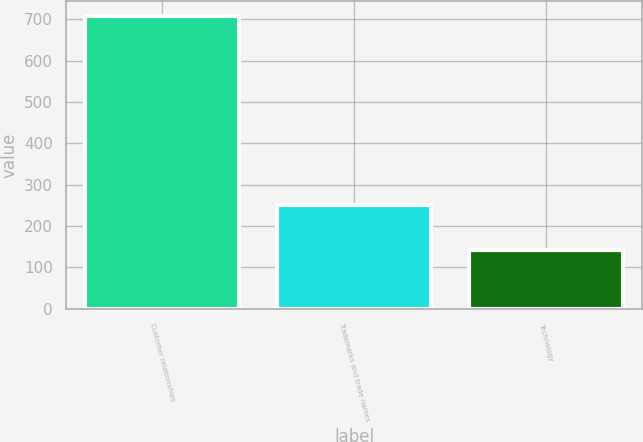Convert chart. <chart><loc_0><loc_0><loc_500><loc_500><bar_chart><fcel>Customer relationships<fcel>Trademarks and trade names<fcel>Technology<nl><fcel>708.5<fcel>251.2<fcel>142.2<nl></chart> 